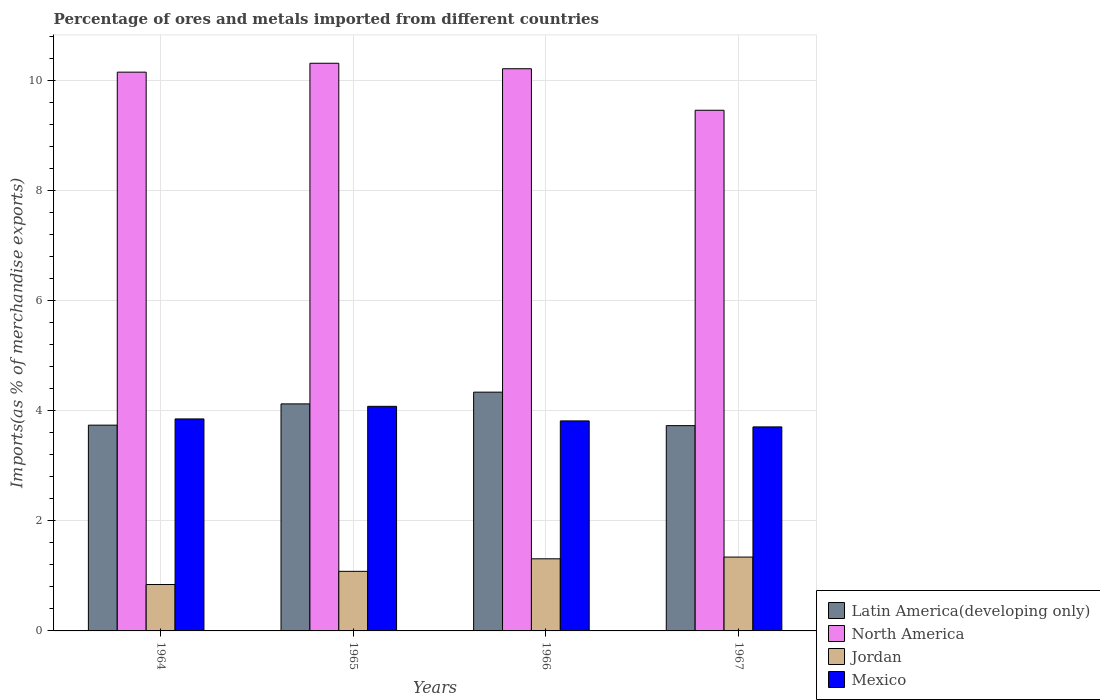How many groups of bars are there?
Offer a very short reply. 4. Are the number of bars per tick equal to the number of legend labels?
Offer a terse response. Yes. Are the number of bars on each tick of the X-axis equal?
Your answer should be very brief. Yes. What is the label of the 3rd group of bars from the left?
Your answer should be very brief. 1966. What is the percentage of imports to different countries in Jordan in 1965?
Make the answer very short. 1.08. Across all years, what is the maximum percentage of imports to different countries in Jordan?
Make the answer very short. 1.34. Across all years, what is the minimum percentage of imports to different countries in Latin America(developing only)?
Your answer should be very brief. 3.73. In which year was the percentage of imports to different countries in North America maximum?
Provide a short and direct response. 1965. In which year was the percentage of imports to different countries in Latin America(developing only) minimum?
Ensure brevity in your answer.  1967. What is the total percentage of imports to different countries in Mexico in the graph?
Your answer should be very brief. 15.46. What is the difference between the percentage of imports to different countries in Jordan in 1965 and that in 1966?
Give a very brief answer. -0.23. What is the difference between the percentage of imports to different countries in Latin America(developing only) in 1965 and the percentage of imports to different countries in North America in 1964?
Offer a very short reply. -6.03. What is the average percentage of imports to different countries in North America per year?
Ensure brevity in your answer.  10.04. In the year 1965, what is the difference between the percentage of imports to different countries in North America and percentage of imports to different countries in Mexico?
Keep it short and to the point. 6.23. What is the ratio of the percentage of imports to different countries in North America in 1966 to that in 1967?
Make the answer very short. 1.08. Is the percentage of imports to different countries in Jordan in 1964 less than that in 1965?
Your answer should be compact. Yes. What is the difference between the highest and the second highest percentage of imports to different countries in Latin America(developing only)?
Provide a succinct answer. 0.21. What is the difference between the highest and the lowest percentage of imports to different countries in Latin America(developing only)?
Give a very brief answer. 0.61. Is it the case that in every year, the sum of the percentage of imports to different countries in Latin America(developing only) and percentage of imports to different countries in Jordan is greater than the sum of percentage of imports to different countries in North America and percentage of imports to different countries in Mexico?
Ensure brevity in your answer.  No. What does the 1st bar from the left in 1964 represents?
Offer a very short reply. Latin America(developing only). What does the 3rd bar from the right in 1964 represents?
Give a very brief answer. North America. How many bars are there?
Offer a very short reply. 16. What is the difference between two consecutive major ticks on the Y-axis?
Give a very brief answer. 2. Are the values on the major ticks of Y-axis written in scientific E-notation?
Give a very brief answer. No. Does the graph contain any zero values?
Provide a succinct answer. No. How are the legend labels stacked?
Give a very brief answer. Vertical. What is the title of the graph?
Provide a succinct answer. Percentage of ores and metals imported from different countries. What is the label or title of the Y-axis?
Offer a terse response. Imports(as % of merchandise exports). What is the Imports(as % of merchandise exports) of Latin America(developing only) in 1964?
Keep it short and to the point. 3.74. What is the Imports(as % of merchandise exports) of North America in 1964?
Give a very brief answer. 10.15. What is the Imports(as % of merchandise exports) of Jordan in 1964?
Make the answer very short. 0.84. What is the Imports(as % of merchandise exports) in Mexico in 1964?
Your answer should be compact. 3.85. What is the Imports(as % of merchandise exports) of Latin America(developing only) in 1965?
Give a very brief answer. 4.13. What is the Imports(as % of merchandise exports) of North America in 1965?
Your response must be concise. 10.31. What is the Imports(as % of merchandise exports) of Jordan in 1965?
Offer a very short reply. 1.08. What is the Imports(as % of merchandise exports) of Mexico in 1965?
Keep it short and to the point. 4.08. What is the Imports(as % of merchandise exports) in Latin America(developing only) in 1966?
Your answer should be compact. 4.34. What is the Imports(as % of merchandise exports) of North America in 1966?
Provide a succinct answer. 10.22. What is the Imports(as % of merchandise exports) of Jordan in 1966?
Provide a short and direct response. 1.31. What is the Imports(as % of merchandise exports) of Mexico in 1966?
Your response must be concise. 3.82. What is the Imports(as % of merchandise exports) in Latin America(developing only) in 1967?
Offer a terse response. 3.73. What is the Imports(as % of merchandise exports) of North America in 1967?
Offer a terse response. 9.46. What is the Imports(as % of merchandise exports) in Jordan in 1967?
Provide a short and direct response. 1.34. What is the Imports(as % of merchandise exports) in Mexico in 1967?
Ensure brevity in your answer.  3.71. Across all years, what is the maximum Imports(as % of merchandise exports) of Latin America(developing only)?
Provide a succinct answer. 4.34. Across all years, what is the maximum Imports(as % of merchandise exports) of North America?
Provide a short and direct response. 10.31. Across all years, what is the maximum Imports(as % of merchandise exports) in Jordan?
Keep it short and to the point. 1.34. Across all years, what is the maximum Imports(as % of merchandise exports) of Mexico?
Ensure brevity in your answer.  4.08. Across all years, what is the minimum Imports(as % of merchandise exports) in Latin America(developing only)?
Your answer should be compact. 3.73. Across all years, what is the minimum Imports(as % of merchandise exports) of North America?
Provide a succinct answer. 9.46. Across all years, what is the minimum Imports(as % of merchandise exports) of Jordan?
Your answer should be compact. 0.84. Across all years, what is the minimum Imports(as % of merchandise exports) in Mexico?
Make the answer very short. 3.71. What is the total Imports(as % of merchandise exports) of Latin America(developing only) in the graph?
Offer a very short reply. 15.93. What is the total Imports(as % of merchandise exports) in North America in the graph?
Provide a succinct answer. 40.14. What is the total Imports(as % of merchandise exports) in Jordan in the graph?
Your response must be concise. 4.58. What is the total Imports(as % of merchandise exports) of Mexico in the graph?
Make the answer very short. 15.46. What is the difference between the Imports(as % of merchandise exports) in Latin America(developing only) in 1964 and that in 1965?
Offer a terse response. -0.39. What is the difference between the Imports(as % of merchandise exports) of North America in 1964 and that in 1965?
Make the answer very short. -0.16. What is the difference between the Imports(as % of merchandise exports) of Jordan in 1964 and that in 1965?
Ensure brevity in your answer.  -0.24. What is the difference between the Imports(as % of merchandise exports) in Mexico in 1964 and that in 1965?
Your answer should be very brief. -0.23. What is the difference between the Imports(as % of merchandise exports) of Latin America(developing only) in 1964 and that in 1966?
Offer a very short reply. -0.6. What is the difference between the Imports(as % of merchandise exports) of North America in 1964 and that in 1966?
Offer a very short reply. -0.06. What is the difference between the Imports(as % of merchandise exports) of Jordan in 1964 and that in 1966?
Provide a succinct answer. -0.47. What is the difference between the Imports(as % of merchandise exports) in Mexico in 1964 and that in 1966?
Your answer should be very brief. 0.04. What is the difference between the Imports(as % of merchandise exports) in Latin America(developing only) in 1964 and that in 1967?
Ensure brevity in your answer.  0.01. What is the difference between the Imports(as % of merchandise exports) in North America in 1964 and that in 1967?
Make the answer very short. 0.69. What is the difference between the Imports(as % of merchandise exports) of Jordan in 1964 and that in 1967?
Ensure brevity in your answer.  -0.5. What is the difference between the Imports(as % of merchandise exports) in Mexico in 1964 and that in 1967?
Provide a succinct answer. 0.14. What is the difference between the Imports(as % of merchandise exports) of Latin America(developing only) in 1965 and that in 1966?
Keep it short and to the point. -0.21. What is the difference between the Imports(as % of merchandise exports) in North America in 1965 and that in 1966?
Provide a succinct answer. 0.1. What is the difference between the Imports(as % of merchandise exports) of Jordan in 1965 and that in 1966?
Provide a succinct answer. -0.23. What is the difference between the Imports(as % of merchandise exports) of Mexico in 1965 and that in 1966?
Give a very brief answer. 0.26. What is the difference between the Imports(as % of merchandise exports) of Latin America(developing only) in 1965 and that in 1967?
Ensure brevity in your answer.  0.4. What is the difference between the Imports(as % of merchandise exports) of North America in 1965 and that in 1967?
Your answer should be very brief. 0.85. What is the difference between the Imports(as % of merchandise exports) in Jordan in 1965 and that in 1967?
Keep it short and to the point. -0.26. What is the difference between the Imports(as % of merchandise exports) in Mexico in 1965 and that in 1967?
Your response must be concise. 0.37. What is the difference between the Imports(as % of merchandise exports) of Latin America(developing only) in 1966 and that in 1967?
Keep it short and to the point. 0.61. What is the difference between the Imports(as % of merchandise exports) in North America in 1966 and that in 1967?
Make the answer very short. 0.75. What is the difference between the Imports(as % of merchandise exports) of Jordan in 1966 and that in 1967?
Your answer should be compact. -0.03. What is the difference between the Imports(as % of merchandise exports) in Mexico in 1966 and that in 1967?
Provide a succinct answer. 0.11. What is the difference between the Imports(as % of merchandise exports) of Latin America(developing only) in 1964 and the Imports(as % of merchandise exports) of North America in 1965?
Keep it short and to the point. -6.58. What is the difference between the Imports(as % of merchandise exports) of Latin America(developing only) in 1964 and the Imports(as % of merchandise exports) of Jordan in 1965?
Your response must be concise. 2.66. What is the difference between the Imports(as % of merchandise exports) of Latin America(developing only) in 1964 and the Imports(as % of merchandise exports) of Mexico in 1965?
Your answer should be compact. -0.34. What is the difference between the Imports(as % of merchandise exports) in North America in 1964 and the Imports(as % of merchandise exports) in Jordan in 1965?
Offer a terse response. 9.07. What is the difference between the Imports(as % of merchandise exports) of North America in 1964 and the Imports(as % of merchandise exports) of Mexico in 1965?
Provide a short and direct response. 6.07. What is the difference between the Imports(as % of merchandise exports) of Jordan in 1964 and the Imports(as % of merchandise exports) of Mexico in 1965?
Ensure brevity in your answer.  -3.24. What is the difference between the Imports(as % of merchandise exports) in Latin America(developing only) in 1964 and the Imports(as % of merchandise exports) in North America in 1966?
Your answer should be very brief. -6.48. What is the difference between the Imports(as % of merchandise exports) of Latin America(developing only) in 1964 and the Imports(as % of merchandise exports) of Jordan in 1966?
Make the answer very short. 2.43. What is the difference between the Imports(as % of merchandise exports) of Latin America(developing only) in 1964 and the Imports(as % of merchandise exports) of Mexico in 1966?
Keep it short and to the point. -0.08. What is the difference between the Imports(as % of merchandise exports) of North America in 1964 and the Imports(as % of merchandise exports) of Jordan in 1966?
Give a very brief answer. 8.84. What is the difference between the Imports(as % of merchandise exports) in North America in 1964 and the Imports(as % of merchandise exports) in Mexico in 1966?
Provide a short and direct response. 6.34. What is the difference between the Imports(as % of merchandise exports) of Jordan in 1964 and the Imports(as % of merchandise exports) of Mexico in 1966?
Your answer should be very brief. -2.97. What is the difference between the Imports(as % of merchandise exports) of Latin America(developing only) in 1964 and the Imports(as % of merchandise exports) of North America in 1967?
Your answer should be very brief. -5.72. What is the difference between the Imports(as % of merchandise exports) in Latin America(developing only) in 1964 and the Imports(as % of merchandise exports) in Jordan in 1967?
Provide a succinct answer. 2.4. What is the difference between the Imports(as % of merchandise exports) in Latin America(developing only) in 1964 and the Imports(as % of merchandise exports) in Mexico in 1967?
Offer a very short reply. 0.03. What is the difference between the Imports(as % of merchandise exports) of North America in 1964 and the Imports(as % of merchandise exports) of Jordan in 1967?
Offer a terse response. 8.81. What is the difference between the Imports(as % of merchandise exports) in North America in 1964 and the Imports(as % of merchandise exports) in Mexico in 1967?
Your answer should be compact. 6.45. What is the difference between the Imports(as % of merchandise exports) of Jordan in 1964 and the Imports(as % of merchandise exports) of Mexico in 1967?
Your answer should be very brief. -2.86. What is the difference between the Imports(as % of merchandise exports) in Latin America(developing only) in 1965 and the Imports(as % of merchandise exports) in North America in 1966?
Keep it short and to the point. -6.09. What is the difference between the Imports(as % of merchandise exports) of Latin America(developing only) in 1965 and the Imports(as % of merchandise exports) of Jordan in 1966?
Provide a short and direct response. 2.81. What is the difference between the Imports(as % of merchandise exports) in Latin America(developing only) in 1965 and the Imports(as % of merchandise exports) in Mexico in 1966?
Your response must be concise. 0.31. What is the difference between the Imports(as % of merchandise exports) of North America in 1965 and the Imports(as % of merchandise exports) of Jordan in 1966?
Make the answer very short. 9. What is the difference between the Imports(as % of merchandise exports) in North America in 1965 and the Imports(as % of merchandise exports) in Mexico in 1966?
Provide a succinct answer. 6.5. What is the difference between the Imports(as % of merchandise exports) in Jordan in 1965 and the Imports(as % of merchandise exports) in Mexico in 1966?
Provide a short and direct response. -2.73. What is the difference between the Imports(as % of merchandise exports) in Latin America(developing only) in 1965 and the Imports(as % of merchandise exports) in North America in 1967?
Ensure brevity in your answer.  -5.34. What is the difference between the Imports(as % of merchandise exports) in Latin America(developing only) in 1965 and the Imports(as % of merchandise exports) in Jordan in 1967?
Provide a short and direct response. 2.78. What is the difference between the Imports(as % of merchandise exports) in Latin America(developing only) in 1965 and the Imports(as % of merchandise exports) in Mexico in 1967?
Provide a succinct answer. 0.42. What is the difference between the Imports(as % of merchandise exports) in North America in 1965 and the Imports(as % of merchandise exports) in Jordan in 1967?
Your answer should be compact. 8.97. What is the difference between the Imports(as % of merchandise exports) in North America in 1965 and the Imports(as % of merchandise exports) in Mexico in 1967?
Ensure brevity in your answer.  6.61. What is the difference between the Imports(as % of merchandise exports) of Jordan in 1965 and the Imports(as % of merchandise exports) of Mexico in 1967?
Keep it short and to the point. -2.62. What is the difference between the Imports(as % of merchandise exports) of Latin America(developing only) in 1966 and the Imports(as % of merchandise exports) of North America in 1967?
Provide a succinct answer. -5.12. What is the difference between the Imports(as % of merchandise exports) in Latin America(developing only) in 1966 and the Imports(as % of merchandise exports) in Jordan in 1967?
Provide a succinct answer. 3. What is the difference between the Imports(as % of merchandise exports) in Latin America(developing only) in 1966 and the Imports(as % of merchandise exports) in Mexico in 1967?
Make the answer very short. 0.63. What is the difference between the Imports(as % of merchandise exports) in North America in 1966 and the Imports(as % of merchandise exports) in Jordan in 1967?
Ensure brevity in your answer.  8.87. What is the difference between the Imports(as % of merchandise exports) of North America in 1966 and the Imports(as % of merchandise exports) of Mexico in 1967?
Your answer should be very brief. 6.51. What is the difference between the Imports(as % of merchandise exports) in Jordan in 1966 and the Imports(as % of merchandise exports) in Mexico in 1967?
Ensure brevity in your answer.  -2.4. What is the average Imports(as % of merchandise exports) in Latin America(developing only) per year?
Your response must be concise. 3.98. What is the average Imports(as % of merchandise exports) in North America per year?
Make the answer very short. 10.04. What is the average Imports(as % of merchandise exports) of Jordan per year?
Ensure brevity in your answer.  1.14. What is the average Imports(as % of merchandise exports) in Mexico per year?
Offer a very short reply. 3.86. In the year 1964, what is the difference between the Imports(as % of merchandise exports) in Latin America(developing only) and Imports(as % of merchandise exports) in North America?
Make the answer very short. -6.41. In the year 1964, what is the difference between the Imports(as % of merchandise exports) in Latin America(developing only) and Imports(as % of merchandise exports) in Jordan?
Offer a terse response. 2.9. In the year 1964, what is the difference between the Imports(as % of merchandise exports) in Latin America(developing only) and Imports(as % of merchandise exports) in Mexico?
Offer a very short reply. -0.11. In the year 1964, what is the difference between the Imports(as % of merchandise exports) in North America and Imports(as % of merchandise exports) in Jordan?
Your response must be concise. 9.31. In the year 1964, what is the difference between the Imports(as % of merchandise exports) in North America and Imports(as % of merchandise exports) in Mexico?
Your answer should be compact. 6.3. In the year 1964, what is the difference between the Imports(as % of merchandise exports) of Jordan and Imports(as % of merchandise exports) of Mexico?
Make the answer very short. -3.01. In the year 1965, what is the difference between the Imports(as % of merchandise exports) of Latin America(developing only) and Imports(as % of merchandise exports) of North America?
Give a very brief answer. -6.19. In the year 1965, what is the difference between the Imports(as % of merchandise exports) in Latin America(developing only) and Imports(as % of merchandise exports) in Jordan?
Give a very brief answer. 3.04. In the year 1965, what is the difference between the Imports(as % of merchandise exports) in Latin America(developing only) and Imports(as % of merchandise exports) in Mexico?
Keep it short and to the point. 0.04. In the year 1965, what is the difference between the Imports(as % of merchandise exports) of North America and Imports(as % of merchandise exports) of Jordan?
Your answer should be very brief. 9.23. In the year 1965, what is the difference between the Imports(as % of merchandise exports) of North America and Imports(as % of merchandise exports) of Mexico?
Your answer should be compact. 6.23. In the year 1965, what is the difference between the Imports(as % of merchandise exports) in Jordan and Imports(as % of merchandise exports) in Mexico?
Provide a short and direct response. -3. In the year 1966, what is the difference between the Imports(as % of merchandise exports) in Latin America(developing only) and Imports(as % of merchandise exports) in North America?
Make the answer very short. -5.88. In the year 1966, what is the difference between the Imports(as % of merchandise exports) of Latin America(developing only) and Imports(as % of merchandise exports) of Jordan?
Your answer should be compact. 3.03. In the year 1966, what is the difference between the Imports(as % of merchandise exports) in Latin America(developing only) and Imports(as % of merchandise exports) in Mexico?
Provide a succinct answer. 0.52. In the year 1966, what is the difference between the Imports(as % of merchandise exports) of North America and Imports(as % of merchandise exports) of Jordan?
Offer a very short reply. 8.9. In the year 1966, what is the difference between the Imports(as % of merchandise exports) of North America and Imports(as % of merchandise exports) of Mexico?
Offer a terse response. 6.4. In the year 1966, what is the difference between the Imports(as % of merchandise exports) of Jordan and Imports(as % of merchandise exports) of Mexico?
Provide a short and direct response. -2.51. In the year 1967, what is the difference between the Imports(as % of merchandise exports) in Latin America(developing only) and Imports(as % of merchandise exports) in North America?
Your answer should be very brief. -5.73. In the year 1967, what is the difference between the Imports(as % of merchandise exports) in Latin America(developing only) and Imports(as % of merchandise exports) in Jordan?
Your answer should be compact. 2.39. In the year 1967, what is the difference between the Imports(as % of merchandise exports) of Latin America(developing only) and Imports(as % of merchandise exports) of Mexico?
Your answer should be very brief. 0.02. In the year 1967, what is the difference between the Imports(as % of merchandise exports) in North America and Imports(as % of merchandise exports) in Jordan?
Offer a terse response. 8.12. In the year 1967, what is the difference between the Imports(as % of merchandise exports) in North America and Imports(as % of merchandise exports) in Mexico?
Your answer should be very brief. 5.75. In the year 1967, what is the difference between the Imports(as % of merchandise exports) in Jordan and Imports(as % of merchandise exports) in Mexico?
Provide a short and direct response. -2.37. What is the ratio of the Imports(as % of merchandise exports) of Latin America(developing only) in 1964 to that in 1965?
Ensure brevity in your answer.  0.91. What is the ratio of the Imports(as % of merchandise exports) of North America in 1964 to that in 1965?
Offer a terse response. 0.98. What is the ratio of the Imports(as % of merchandise exports) of Jordan in 1964 to that in 1965?
Your answer should be very brief. 0.78. What is the ratio of the Imports(as % of merchandise exports) in Mexico in 1964 to that in 1965?
Provide a succinct answer. 0.94. What is the ratio of the Imports(as % of merchandise exports) of Latin America(developing only) in 1964 to that in 1966?
Provide a short and direct response. 0.86. What is the ratio of the Imports(as % of merchandise exports) in North America in 1964 to that in 1966?
Offer a very short reply. 0.99. What is the ratio of the Imports(as % of merchandise exports) of Jordan in 1964 to that in 1966?
Offer a terse response. 0.64. What is the ratio of the Imports(as % of merchandise exports) in Mexico in 1964 to that in 1966?
Your response must be concise. 1.01. What is the ratio of the Imports(as % of merchandise exports) of North America in 1964 to that in 1967?
Provide a short and direct response. 1.07. What is the ratio of the Imports(as % of merchandise exports) of Jordan in 1964 to that in 1967?
Your answer should be very brief. 0.63. What is the ratio of the Imports(as % of merchandise exports) in Mexico in 1964 to that in 1967?
Offer a very short reply. 1.04. What is the ratio of the Imports(as % of merchandise exports) of Latin America(developing only) in 1965 to that in 1966?
Provide a short and direct response. 0.95. What is the ratio of the Imports(as % of merchandise exports) in North America in 1965 to that in 1966?
Make the answer very short. 1.01. What is the ratio of the Imports(as % of merchandise exports) of Jordan in 1965 to that in 1966?
Your answer should be compact. 0.83. What is the ratio of the Imports(as % of merchandise exports) of Mexico in 1965 to that in 1966?
Provide a short and direct response. 1.07. What is the ratio of the Imports(as % of merchandise exports) in Latin America(developing only) in 1965 to that in 1967?
Offer a terse response. 1.11. What is the ratio of the Imports(as % of merchandise exports) of North America in 1965 to that in 1967?
Provide a succinct answer. 1.09. What is the ratio of the Imports(as % of merchandise exports) of Jordan in 1965 to that in 1967?
Offer a very short reply. 0.81. What is the ratio of the Imports(as % of merchandise exports) of Mexico in 1965 to that in 1967?
Offer a terse response. 1.1. What is the ratio of the Imports(as % of merchandise exports) of Latin America(developing only) in 1966 to that in 1967?
Your answer should be very brief. 1.16. What is the ratio of the Imports(as % of merchandise exports) of North America in 1966 to that in 1967?
Ensure brevity in your answer.  1.08. What is the ratio of the Imports(as % of merchandise exports) of Jordan in 1966 to that in 1967?
Provide a succinct answer. 0.98. What is the ratio of the Imports(as % of merchandise exports) of Mexico in 1966 to that in 1967?
Provide a succinct answer. 1.03. What is the difference between the highest and the second highest Imports(as % of merchandise exports) of Latin America(developing only)?
Ensure brevity in your answer.  0.21. What is the difference between the highest and the second highest Imports(as % of merchandise exports) of North America?
Provide a succinct answer. 0.1. What is the difference between the highest and the second highest Imports(as % of merchandise exports) in Jordan?
Make the answer very short. 0.03. What is the difference between the highest and the second highest Imports(as % of merchandise exports) of Mexico?
Ensure brevity in your answer.  0.23. What is the difference between the highest and the lowest Imports(as % of merchandise exports) in Latin America(developing only)?
Keep it short and to the point. 0.61. What is the difference between the highest and the lowest Imports(as % of merchandise exports) of North America?
Offer a terse response. 0.85. What is the difference between the highest and the lowest Imports(as % of merchandise exports) of Jordan?
Provide a short and direct response. 0.5. What is the difference between the highest and the lowest Imports(as % of merchandise exports) in Mexico?
Your answer should be very brief. 0.37. 